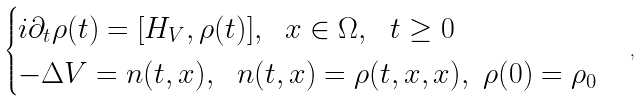Convert formula to latex. <formula><loc_0><loc_0><loc_500><loc_500>\begin{cases} i \partial _ { t } { \rho ( t ) } = [ H _ { V } , \rho ( t ) ] , \ \ x \in \Omega , \ \ t \geq 0 \\ - \Delta V = n ( t , x ) , \ \ n ( t , x ) = \rho ( t , x , x ) , \ \rho ( 0 ) = \rho _ { 0 } \end{cases} ,</formula> 